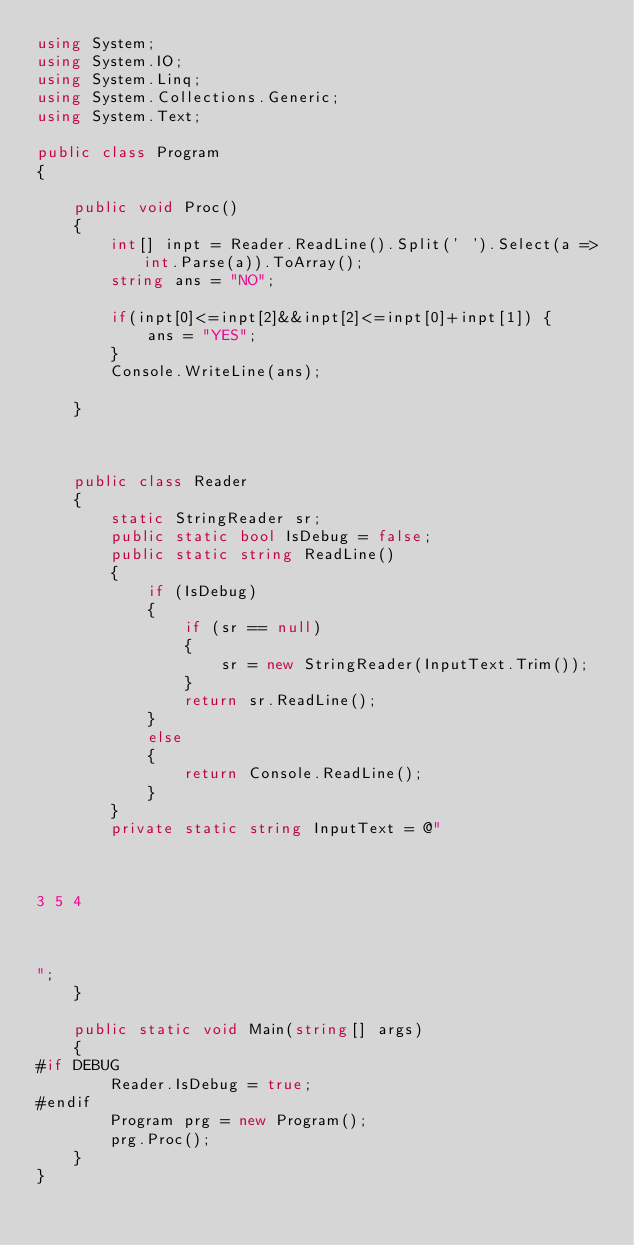<code> <loc_0><loc_0><loc_500><loc_500><_C#_>using System;
using System.IO;
using System.Linq;
using System.Collections.Generic;
using System.Text;

public class Program
{

    public void Proc()
    {
        int[] inpt = Reader.ReadLine().Split(' ').Select(a => int.Parse(a)).ToArray();
        string ans = "NO";

        if(inpt[0]<=inpt[2]&&inpt[2]<=inpt[0]+inpt[1]) {
            ans = "YES";
        }
        Console.WriteLine(ans);
    
    }



    public class Reader
    {
        static StringReader sr;
        public static bool IsDebug = false;
        public static string ReadLine()
        {
            if (IsDebug)
            {
                if (sr == null)
                {
                    sr = new StringReader(InputText.Trim());
                }
                return sr.ReadLine();
            }
            else
            {
                return Console.ReadLine();
            }
        }
        private static string InputText = @"



3 5 4



";
    }

    public static void Main(string[] args)
    {
#if DEBUG
        Reader.IsDebug = true;
#endif
        Program prg = new Program();
        prg.Proc();
    }
}
</code> 